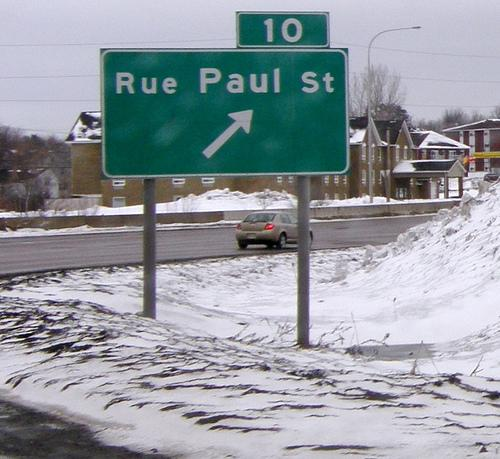Identify the type of vehicle present in the image and mention its color. There is a small, light brown or beige car on the road with red taillights. Mention the main details about the street sign in the image. The street sign is green with white words and an arrow on it, supported by two metal poles. Describe the state of the weather in the scene based on visual cues. It seems to be after a snowfall since there is snow on the ground, hills, and roofs of the buildings. Comment on the quality of the snow as seen in the image. The snow appears to be fairly clean and appears pretty white. Count the number of visible objects related to traffic and road infrastructure in the image. There are 6 objects: a green street sign, two poles supporting the sign, a silver light pole, a car running on the road, and red taillights on the car. How many buildings can be seen in the image and how do they look? There are a group of brown buildings in the background with snow-covered roofs. Analyze the general sentiment or emotion associated with the image. The image has a peaceful and wintery sentiment with the snow-covered ground and buildings, and cold weather elements. Explain the condition of the ground and surroundings in the image. The ground has white snow, dead weeds are sticking through it, and there's snow on the hill and on the side of the street. What are the dominating colors and elements present in the image? The dominating colors are green, white, and brown, featuring a green street sign, white snow, and brown buildings. Describe any interactions between objects or elements in the image. The car is moving on the road, the sign is providing information to drivers, and the light pole illuminates the street. Identify a relationship between objects in the image involving heights. The light pole is taller than the two poles holding the green sign. What are the two poles holding? A green sign. Can you see the yellow bicycle near the car? It's probably in great need of maintenance. No, it's not mentioned in the image. What color are the roofs covered with snow? Black How can you describe the texture of the snow in the image? The snow is pretty white. Is the arrow on the sign white or black? White List the different locations in the image where you can see snow. On the ground, on the side of the street, on rooftops, on a hill, and on a field. What is the main color of the buildings on the side of the road? Brown Create a multimedia presentation about the image. Not applicable, as it is a text-based response. Which direction is indicated by the arrow on the sign? Cannot determine as the direction is not mentioned. How would you describe the car in the image? A light brown or beige car with red brake lights on, running on a black pavement highway. Where is the green traffic sign located in the scene? On the side of the road. Describe the sign with the number 10 on it. A green sign with the number 10 on it. What is an observable event happening in the image that involves movement? A car running on the road. What color is the sign on two metal poles? Green What do the words on the green street sign say? Rue Paul St What color are the taillights of the car in the image? Red What type of sign is attached to the two poles? A green street sign. 